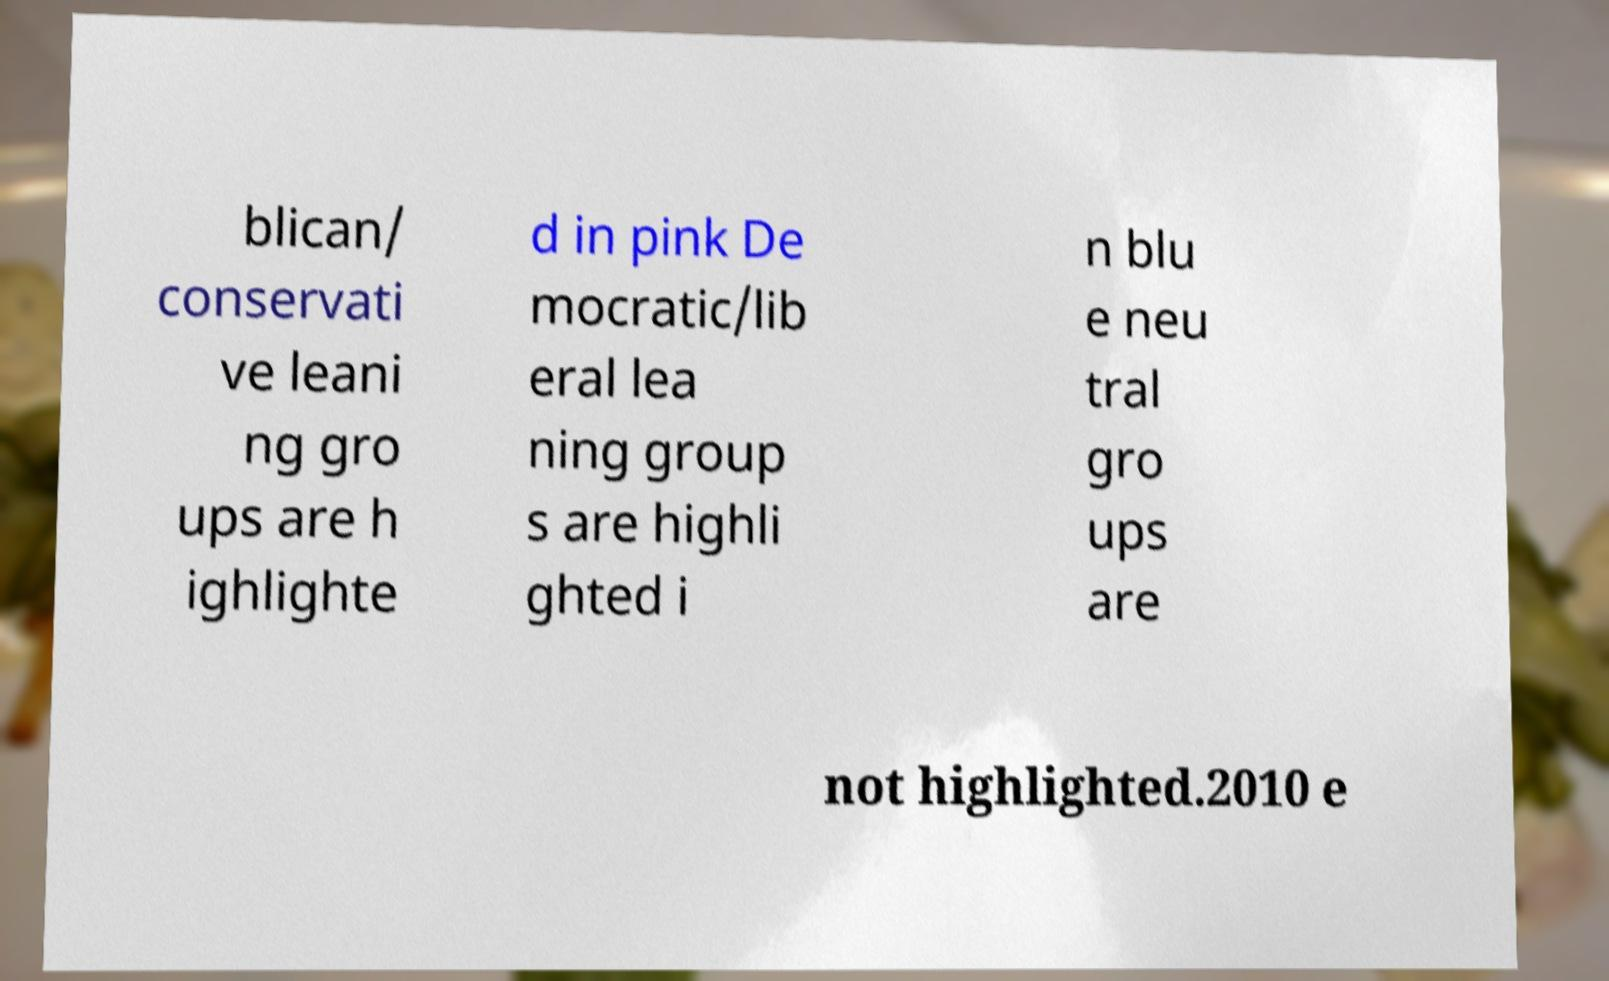Please identify and transcribe the text found in this image. blican/ conservati ve leani ng gro ups are h ighlighte d in pink De mocratic/lib eral lea ning group s are highli ghted i n blu e neu tral gro ups are not highlighted.2010 e 